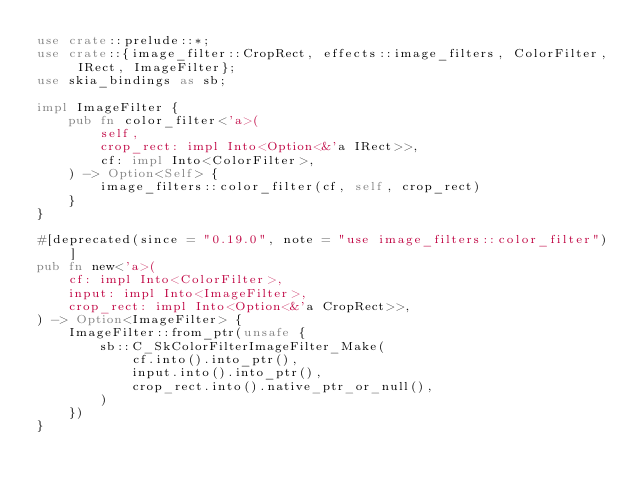Convert code to text. <code><loc_0><loc_0><loc_500><loc_500><_Rust_>use crate::prelude::*;
use crate::{image_filter::CropRect, effects::image_filters, ColorFilter, IRect, ImageFilter};
use skia_bindings as sb;

impl ImageFilter {
    pub fn color_filter<'a>(
        self,
        crop_rect: impl Into<Option<&'a IRect>>,
        cf: impl Into<ColorFilter>,
    ) -> Option<Self> {
        image_filters::color_filter(cf, self, crop_rect)
    }
}

#[deprecated(since = "0.19.0", note = "use image_filters::color_filter")]
pub fn new<'a>(
    cf: impl Into<ColorFilter>,
    input: impl Into<ImageFilter>,
    crop_rect: impl Into<Option<&'a CropRect>>,
) -> Option<ImageFilter> {
    ImageFilter::from_ptr(unsafe {
        sb::C_SkColorFilterImageFilter_Make(
            cf.into().into_ptr(),
            input.into().into_ptr(),
            crop_rect.into().native_ptr_or_null(),
        )
    })
}
</code> 